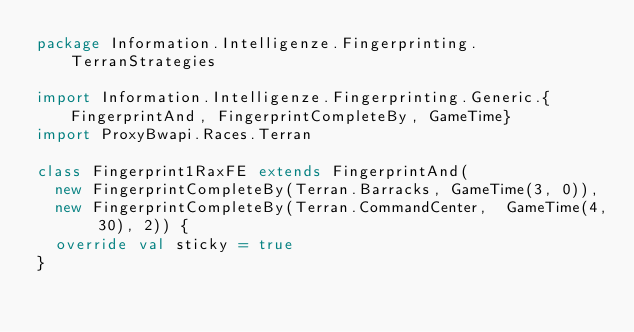<code> <loc_0><loc_0><loc_500><loc_500><_Scala_>package Information.Intelligenze.Fingerprinting.TerranStrategies

import Information.Intelligenze.Fingerprinting.Generic.{FingerprintAnd, FingerprintCompleteBy, GameTime}
import ProxyBwapi.Races.Terran

class Fingerprint1RaxFE extends FingerprintAnd(
  new FingerprintCompleteBy(Terran.Barracks, GameTime(3, 0)),
  new FingerprintCompleteBy(Terran.CommandCenter,  GameTime(4, 30), 2)) {
  override val sticky = true
}
</code> 